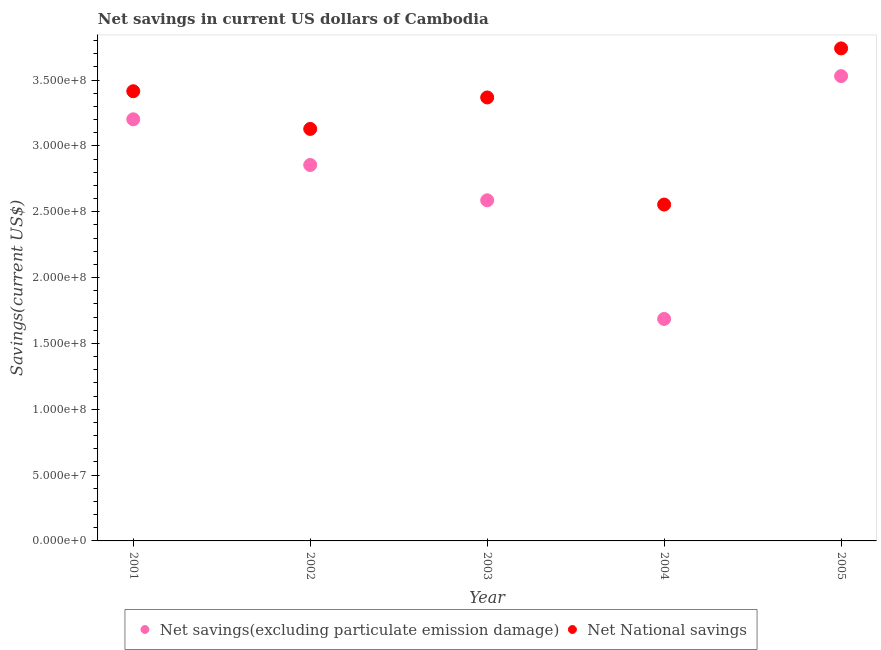Is the number of dotlines equal to the number of legend labels?
Make the answer very short. Yes. What is the net savings(excluding particulate emission damage) in 2001?
Offer a terse response. 3.20e+08. Across all years, what is the maximum net national savings?
Keep it short and to the point. 3.74e+08. Across all years, what is the minimum net national savings?
Give a very brief answer. 2.56e+08. In which year was the net national savings minimum?
Your answer should be very brief. 2004. What is the total net savings(excluding particulate emission damage) in the graph?
Your response must be concise. 1.39e+09. What is the difference between the net savings(excluding particulate emission damage) in 2002 and that in 2003?
Your answer should be compact. 2.68e+07. What is the difference between the net national savings in 2001 and the net savings(excluding particulate emission damage) in 2004?
Offer a very short reply. 1.73e+08. What is the average net savings(excluding particulate emission damage) per year?
Keep it short and to the point. 2.77e+08. In the year 2004, what is the difference between the net national savings and net savings(excluding particulate emission damage)?
Your answer should be very brief. 8.69e+07. What is the ratio of the net national savings in 2001 to that in 2005?
Make the answer very short. 0.91. Is the net national savings in 2004 less than that in 2005?
Your answer should be compact. Yes. Is the difference between the net savings(excluding particulate emission damage) in 2002 and 2003 greater than the difference between the net national savings in 2002 and 2003?
Ensure brevity in your answer.  Yes. What is the difference between the highest and the second highest net national savings?
Offer a terse response. 3.25e+07. What is the difference between the highest and the lowest net savings(excluding particulate emission damage)?
Your response must be concise. 1.84e+08. In how many years, is the net savings(excluding particulate emission damage) greater than the average net savings(excluding particulate emission damage) taken over all years?
Your response must be concise. 3. Is the sum of the net national savings in 2002 and 2005 greater than the maximum net savings(excluding particulate emission damage) across all years?
Keep it short and to the point. Yes. Is the net savings(excluding particulate emission damage) strictly greater than the net national savings over the years?
Your answer should be very brief. No. How many dotlines are there?
Offer a very short reply. 2. How many years are there in the graph?
Make the answer very short. 5. What is the difference between two consecutive major ticks on the Y-axis?
Your answer should be compact. 5.00e+07. Are the values on the major ticks of Y-axis written in scientific E-notation?
Ensure brevity in your answer.  Yes. Does the graph contain grids?
Make the answer very short. No. How many legend labels are there?
Provide a succinct answer. 2. What is the title of the graph?
Give a very brief answer. Net savings in current US dollars of Cambodia. What is the label or title of the X-axis?
Your response must be concise. Year. What is the label or title of the Y-axis?
Your answer should be compact. Savings(current US$). What is the Savings(current US$) of Net savings(excluding particulate emission damage) in 2001?
Your answer should be compact. 3.20e+08. What is the Savings(current US$) of Net National savings in 2001?
Give a very brief answer. 3.42e+08. What is the Savings(current US$) in Net savings(excluding particulate emission damage) in 2002?
Provide a short and direct response. 2.86e+08. What is the Savings(current US$) in Net National savings in 2002?
Ensure brevity in your answer.  3.13e+08. What is the Savings(current US$) in Net savings(excluding particulate emission damage) in 2003?
Keep it short and to the point. 2.59e+08. What is the Savings(current US$) in Net National savings in 2003?
Provide a succinct answer. 3.37e+08. What is the Savings(current US$) of Net savings(excluding particulate emission damage) in 2004?
Provide a short and direct response. 1.69e+08. What is the Savings(current US$) of Net National savings in 2004?
Provide a succinct answer. 2.56e+08. What is the Savings(current US$) of Net savings(excluding particulate emission damage) in 2005?
Make the answer very short. 3.53e+08. What is the Savings(current US$) in Net National savings in 2005?
Your response must be concise. 3.74e+08. Across all years, what is the maximum Savings(current US$) of Net savings(excluding particulate emission damage)?
Your answer should be compact. 3.53e+08. Across all years, what is the maximum Savings(current US$) of Net National savings?
Your response must be concise. 3.74e+08. Across all years, what is the minimum Savings(current US$) of Net savings(excluding particulate emission damage)?
Make the answer very short. 1.69e+08. Across all years, what is the minimum Savings(current US$) in Net National savings?
Provide a short and direct response. 2.56e+08. What is the total Savings(current US$) of Net savings(excluding particulate emission damage) in the graph?
Keep it short and to the point. 1.39e+09. What is the total Savings(current US$) in Net National savings in the graph?
Provide a short and direct response. 1.62e+09. What is the difference between the Savings(current US$) in Net savings(excluding particulate emission damage) in 2001 and that in 2002?
Ensure brevity in your answer.  3.47e+07. What is the difference between the Savings(current US$) in Net National savings in 2001 and that in 2002?
Ensure brevity in your answer.  2.86e+07. What is the difference between the Savings(current US$) of Net savings(excluding particulate emission damage) in 2001 and that in 2003?
Offer a very short reply. 6.15e+07. What is the difference between the Savings(current US$) of Net National savings in 2001 and that in 2003?
Your answer should be very brief. 4.73e+06. What is the difference between the Savings(current US$) in Net savings(excluding particulate emission damage) in 2001 and that in 2004?
Your answer should be very brief. 1.52e+08. What is the difference between the Savings(current US$) in Net National savings in 2001 and that in 2004?
Your response must be concise. 8.61e+07. What is the difference between the Savings(current US$) in Net savings(excluding particulate emission damage) in 2001 and that in 2005?
Your response must be concise. -3.28e+07. What is the difference between the Savings(current US$) of Net National savings in 2001 and that in 2005?
Make the answer very short. -3.25e+07. What is the difference between the Savings(current US$) of Net savings(excluding particulate emission damage) in 2002 and that in 2003?
Provide a succinct answer. 2.68e+07. What is the difference between the Savings(current US$) in Net National savings in 2002 and that in 2003?
Your answer should be very brief. -2.39e+07. What is the difference between the Savings(current US$) of Net savings(excluding particulate emission damage) in 2002 and that in 2004?
Make the answer very short. 1.17e+08. What is the difference between the Savings(current US$) in Net National savings in 2002 and that in 2004?
Provide a succinct answer. 5.75e+07. What is the difference between the Savings(current US$) of Net savings(excluding particulate emission damage) in 2002 and that in 2005?
Your response must be concise. -6.75e+07. What is the difference between the Savings(current US$) in Net National savings in 2002 and that in 2005?
Give a very brief answer. -6.12e+07. What is the difference between the Savings(current US$) of Net savings(excluding particulate emission damage) in 2003 and that in 2004?
Give a very brief answer. 9.01e+07. What is the difference between the Savings(current US$) of Net National savings in 2003 and that in 2004?
Give a very brief answer. 8.14e+07. What is the difference between the Savings(current US$) in Net savings(excluding particulate emission damage) in 2003 and that in 2005?
Your answer should be very brief. -9.43e+07. What is the difference between the Savings(current US$) in Net National savings in 2003 and that in 2005?
Give a very brief answer. -3.73e+07. What is the difference between the Savings(current US$) in Net savings(excluding particulate emission damage) in 2004 and that in 2005?
Make the answer very short. -1.84e+08. What is the difference between the Savings(current US$) of Net National savings in 2004 and that in 2005?
Your response must be concise. -1.19e+08. What is the difference between the Savings(current US$) of Net savings(excluding particulate emission damage) in 2001 and the Savings(current US$) of Net National savings in 2002?
Your answer should be very brief. 7.31e+06. What is the difference between the Savings(current US$) in Net savings(excluding particulate emission damage) in 2001 and the Savings(current US$) in Net National savings in 2003?
Keep it short and to the point. -1.66e+07. What is the difference between the Savings(current US$) in Net savings(excluding particulate emission damage) in 2001 and the Savings(current US$) in Net National savings in 2004?
Give a very brief answer. 6.48e+07. What is the difference between the Savings(current US$) in Net savings(excluding particulate emission damage) in 2001 and the Savings(current US$) in Net National savings in 2005?
Provide a succinct answer. -5.39e+07. What is the difference between the Savings(current US$) of Net savings(excluding particulate emission damage) in 2002 and the Savings(current US$) of Net National savings in 2003?
Give a very brief answer. -5.13e+07. What is the difference between the Savings(current US$) in Net savings(excluding particulate emission damage) in 2002 and the Savings(current US$) in Net National savings in 2004?
Provide a succinct answer. 3.01e+07. What is the difference between the Savings(current US$) of Net savings(excluding particulate emission damage) in 2002 and the Savings(current US$) of Net National savings in 2005?
Provide a short and direct response. -8.86e+07. What is the difference between the Savings(current US$) in Net savings(excluding particulate emission damage) in 2003 and the Savings(current US$) in Net National savings in 2004?
Ensure brevity in your answer.  3.24e+06. What is the difference between the Savings(current US$) in Net savings(excluding particulate emission damage) in 2003 and the Savings(current US$) in Net National savings in 2005?
Provide a short and direct response. -1.15e+08. What is the difference between the Savings(current US$) of Net savings(excluding particulate emission damage) in 2004 and the Savings(current US$) of Net National savings in 2005?
Ensure brevity in your answer.  -2.05e+08. What is the average Savings(current US$) in Net savings(excluding particulate emission damage) per year?
Make the answer very short. 2.77e+08. What is the average Savings(current US$) in Net National savings per year?
Provide a short and direct response. 3.24e+08. In the year 2001, what is the difference between the Savings(current US$) in Net savings(excluding particulate emission damage) and Savings(current US$) in Net National savings?
Your answer should be very brief. -2.13e+07. In the year 2002, what is the difference between the Savings(current US$) of Net savings(excluding particulate emission damage) and Savings(current US$) of Net National savings?
Provide a short and direct response. -2.74e+07. In the year 2003, what is the difference between the Savings(current US$) of Net savings(excluding particulate emission damage) and Savings(current US$) of Net National savings?
Provide a succinct answer. -7.81e+07. In the year 2004, what is the difference between the Savings(current US$) in Net savings(excluding particulate emission damage) and Savings(current US$) in Net National savings?
Offer a terse response. -8.69e+07. In the year 2005, what is the difference between the Savings(current US$) in Net savings(excluding particulate emission damage) and Savings(current US$) in Net National savings?
Ensure brevity in your answer.  -2.11e+07. What is the ratio of the Savings(current US$) in Net savings(excluding particulate emission damage) in 2001 to that in 2002?
Give a very brief answer. 1.12. What is the ratio of the Savings(current US$) in Net National savings in 2001 to that in 2002?
Your answer should be very brief. 1.09. What is the ratio of the Savings(current US$) in Net savings(excluding particulate emission damage) in 2001 to that in 2003?
Your answer should be very brief. 1.24. What is the ratio of the Savings(current US$) of Net savings(excluding particulate emission damage) in 2001 to that in 2004?
Give a very brief answer. 1.9. What is the ratio of the Savings(current US$) in Net National savings in 2001 to that in 2004?
Provide a short and direct response. 1.34. What is the ratio of the Savings(current US$) of Net savings(excluding particulate emission damage) in 2001 to that in 2005?
Offer a terse response. 0.91. What is the ratio of the Savings(current US$) of Net National savings in 2001 to that in 2005?
Provide a short and direct response. 0.91. What is the ratio of the Savings(current US$) in Net savings(excluding particulate emission damage) in 2002 to that in 2003?
Provide a succinct answer. 1.1. What is the ratio of the Savings(current US$) in Net National savings in 2002 to that in 2003?
Offer a very short reply. 0.93. What is the ratio of the Savings(current US$) in Net savings(excluding particulate emission damage) in 2002 to that in 2004?
Make the answer very short. 1.69. What is the ratio of the Savings(current US$) of Net National savings in 2002 to that in 2004?
Ensure brevity in your answer.  1.22. What is the ratio of the Savings(current US$) in Net savings(excluding particulate emission damage) in 2002 to that in 2005?
Provide a short and direct response. 0.81. What is the ratio of the Savings(current US$) of Net National savings in 2002 to that in 2005?
Your answer should be compact. 0.84. What is the ratio of the Savings(current US$) of Net savings(excluding particulate emission damage) in 2003 to that in 2004?
Ensure brevity in your answer.  1.53. What is the ratio of the Savings(current US$) of Net National savings in 2003 to that in 2004?
Ensure brevity in your answer.  1.32. What is the ratio of the Savings(current US$) in Net savings(excluding particulate emission damage) in 2003 to that in 2005?
Your answer should be very brief. 0.73. What is the ratio of the Savings(current US$) in Net National savings in 2003 to that in 2005?
Offer a very short reply. 0.9. What is the ratio of the Savings(current US$) of Net savings(excluding particulate emission damage) in 2004 to that in 2005?
Offer a terse response. 0.48. What is the ratio of the Savings(current US$) in Net National savings in 2004 to that in 2005?
Make the answer very short. 0.68. What is the difference between the highest and the second highest Savings(current US$) of Net savings(excluding particulate emission damage)?
Give a very brief answer. 3.28e+07. What is the difference between the highest and the second highest Savings(current US$) in Net National savings?
Give a very brief answer. 3.25e+07. What is the difference between the highest and the lowest Savings(current US$) in Net savings(excluding particulate emission damage)?
Make the answer very short. 1.84e+08. What is the difference between the highest and the lowest Savings(current US$) of Net National savings?
Your answer should be very brief. 1.19e+08. 